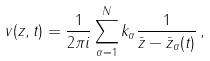<formula> <loc_0><loc_0><loc_500><loc_500>v ( z , t ) = \frac { 1 } { 2 \pi i } \sum _ { \alpha = 1 } ^ { N } k _ { \alpha } \frac { 1 } { \bar { z } - \bar { z } _ { \alpha } ( t ) } \, ,</formula> 